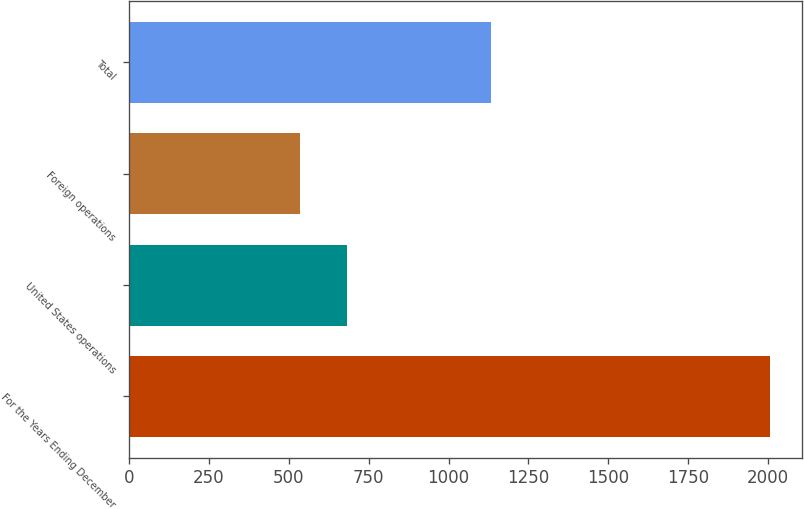Convert chart to OTSL. <chart><loc_0><loc_0><loc_500><loc_500><bar_chart><fcel>For the Years Ending December<fcel>United States operations<fcel>Foreign operations<fcel>Total<nl><fcel>2007<fcel>681.84<fcel>534.6<fcel>1131.6<nl></chart> 